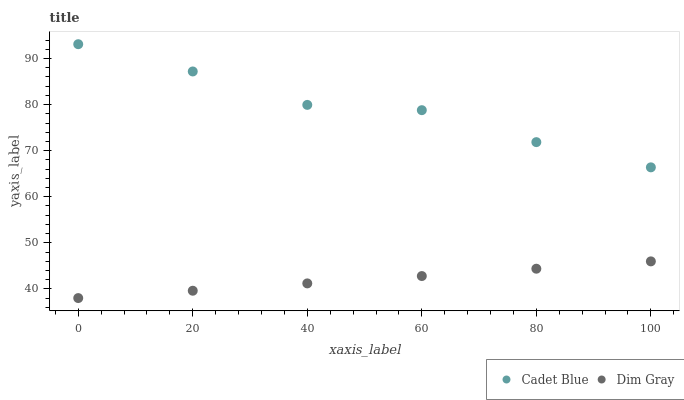Does Dim Gray have the minimum area under the curve?
Answer yes or no. Yes. Does Cadet Blue have the maximum area under the curve?
Answer yes or no. Yes. Does Cadet Blue have the minimum area under the curve?
Answer yes or no. No. Is Dim Gray the smoothest?
Answer yes or no. Yes. Is Cadet Blue the roughest?
Answer yes or no. Yes. Is Cadet Blue the smoothest?
Answer yes or no. No. Does Dim Gray have the lowest value?
Answer yes or no. Yes. Does Cadet Blue have the lowest value?
Answer yes or no. No. Does Cadet Blue have the highest value?
Answer yes or no. Yes. Is Dim Gray less than Cadet Blue?
Answer yes or no. Yes. Is Cadet Blue greater than Dim Gray?
Answer yes or no. Yes. Does Dim Gray intersect Cadet Blue?
Answer yes or no. No. 